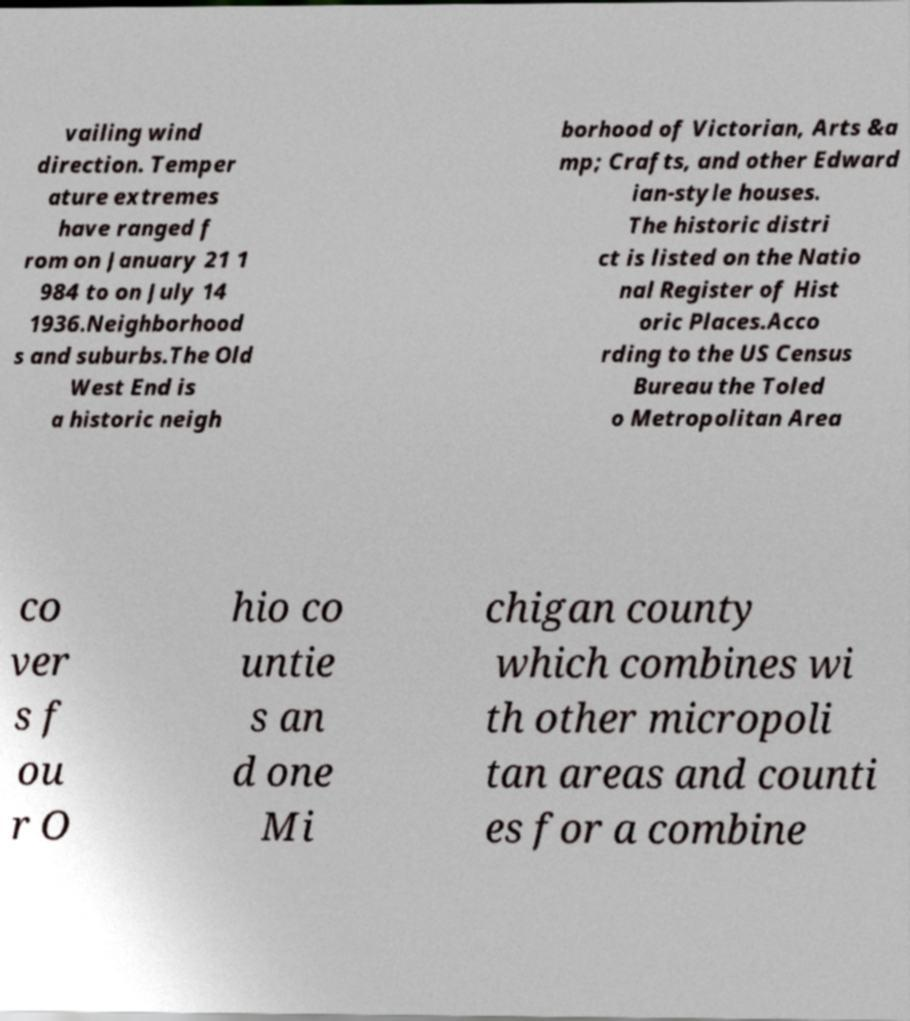Can you accurately transcribe the text from the provided image for me? vailing wind direction. Temper ature extremes have ranged f rom on January 21 1 984 to on July 14 1936.Neighborhood s and suburbs.The Old West End is a historic neigh borhood of Victorian, Arts &a mp; Crafts, and other Edward ian-style houses. The historic distri ct is listed on the Natio nal Register of Hist oric Places.Acco rding to the US Census Bureau the Toled o Metropolitan Area co ver s f ou r O hio co untie s an d one Mi chigan county which combines wi th other micropoli tan areas and counti es for a combine 